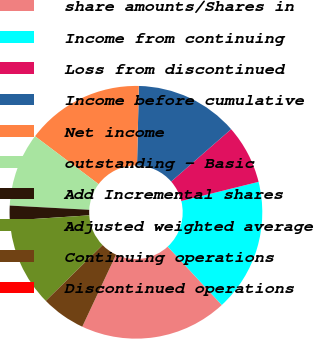Convert chart to OTSL. <chart><loc_0><loc_0><loc_500><loc_500><pie_chart><fcel>share amounts/Shares in<fcel>Income from continuing<fcel>Loss from discontinued<fcel>Income before cumulative<fcel>Net income<fcel>outstanding - Basic<fcel>Add Incremental shares<fcel>Adjusted weighted average<fcel>Continuing operations<fcel>Discontinued operations<nl><fcel>18.87%<fcel>16.98%<fcel>7.55%<fcel>13.21%<fcel>15.09%<fcel>9.43%<fcel>1.89%<fcel>11.32%<fcel>5.66%<fcel>0.0%<nl></chart> 